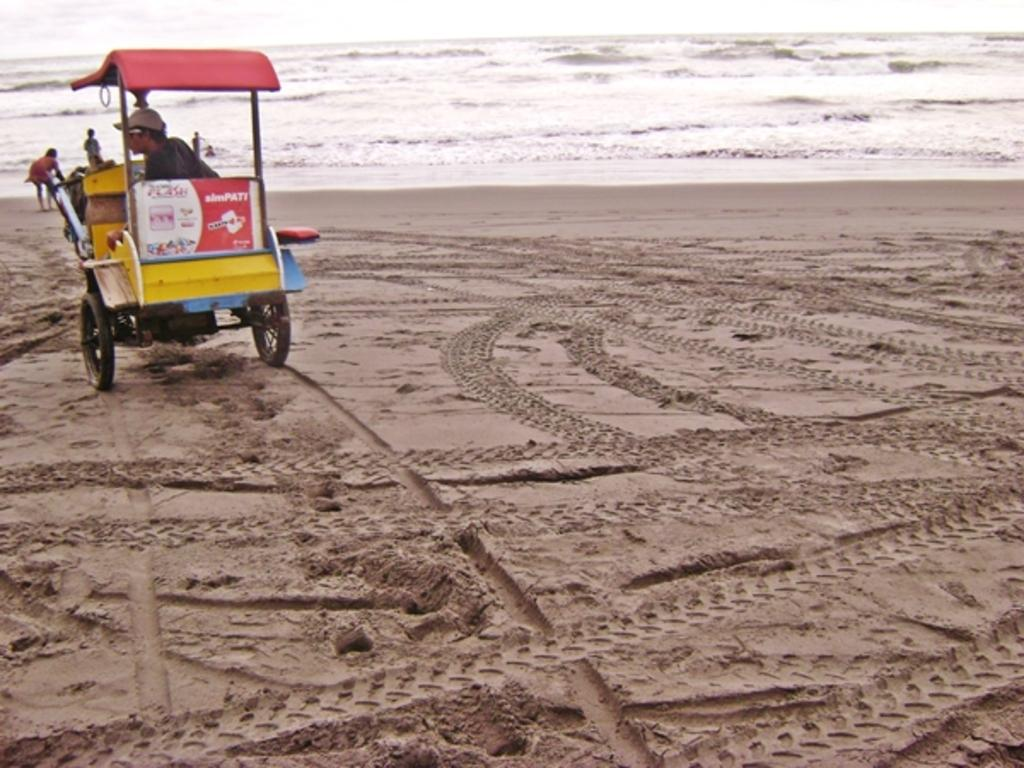What is the main object in the image? There is a cart in the image. Who or what is near the cart? There are people in the image. What type of environment is depicted in the image? Sand and water are present in the image, suggesting a beach or coastal setting. What topic are the people discussing in the image? There is no indication of a discussion taking place in the image, as the focus is on the cart and the beach setting. 